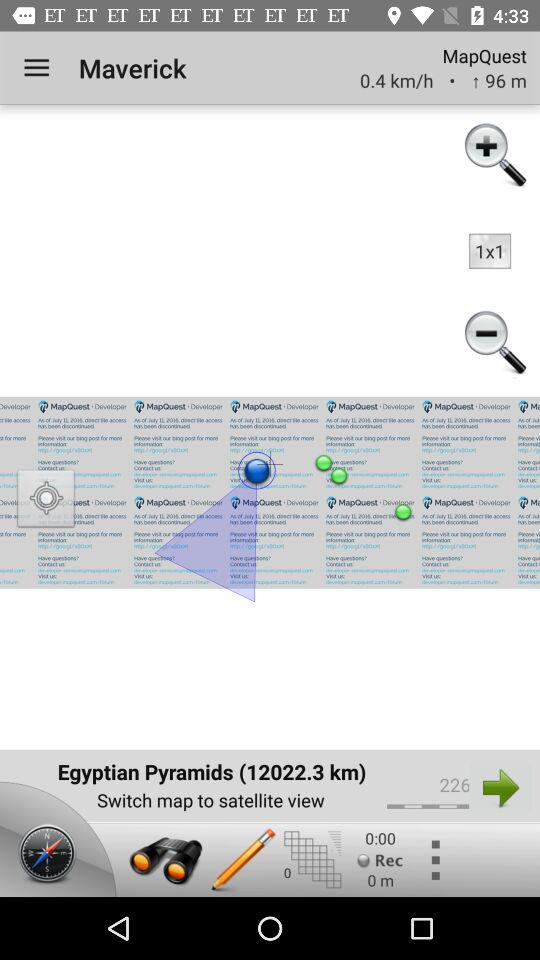How many kilometers per hour has been displayed? The kilometers per hour that has been displayed is 0.4. 